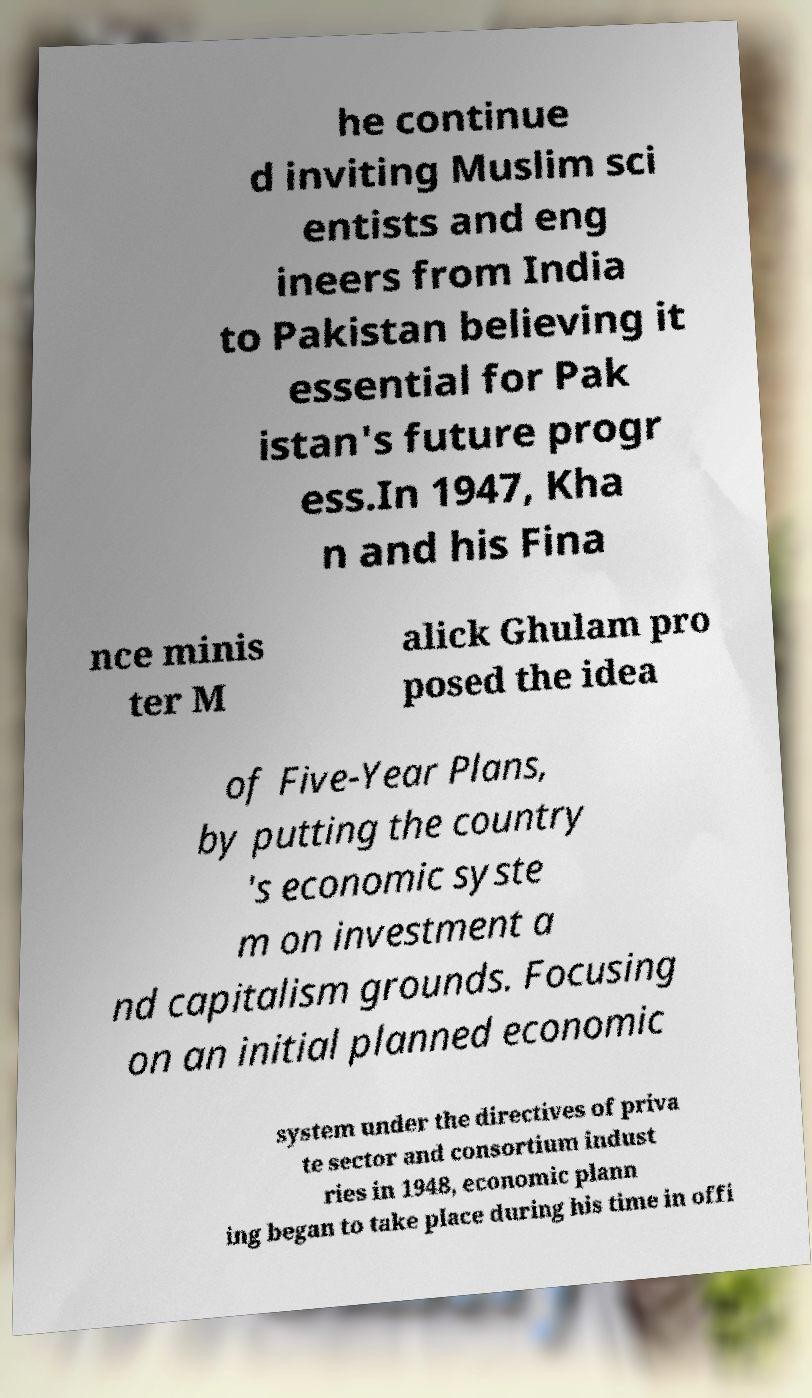Please read and relay the text visible in this image. What does it say? he continue d inviting Muslim sci entists and eng ineers from India to Pakistan believing it essential for Pak istan's future progr ess.In 1947, Kha n and his Fina nce minis ter M alick Ghulam pro posed the idea of Five-Year Plans, by putting the country 's economic syste m on investment a nd capitalism grounds. Focusing on an initial planned economic system under the directives of priva te sector and consortium indust ries in 1948, economic plann ing began to take place during his time in offi 